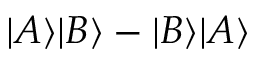Convert formula to latex. <formula><loc_0><loc_0><loc_500><loc_500>| A \rangle | B \rangle - | B \rangle | A \rangle</formula> 